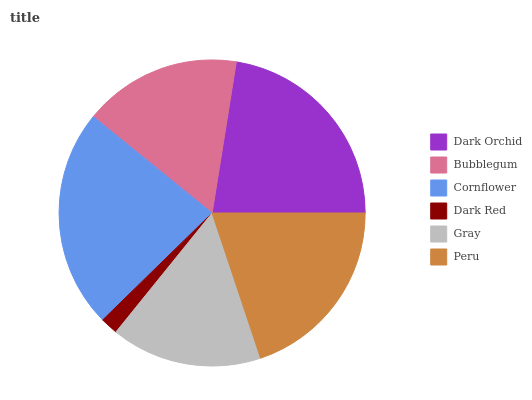Is Dark Red the minimum?
Answer yes or no. Yes. Is Cornflower the maximum?
Answer yes or no. Yes. Is Bubblegum the minimum?
Answer yes or no. No. Is Bubblegum the maximum?
Answer yes or no. No. Is Dark Orchid greater than Bubblegum?
Answer yes or no. Yes. Is Bubblegum less than Dark Orchid?
Answer yes or no. Yes. Is Bubblegum greater than Dark Orchid?
Answer yes or no. No. Is Dark Orchid less than Bubblegum?
Answer yes or no. No. Is Peru the high median?
Answer yes or no. Yes. Is Bubblegum the low median?
Answer yes or no. Yes. Is Cornflower the high median?
Answer yes or no. No. Is Gray the low median?
Answer yes or no. No. 